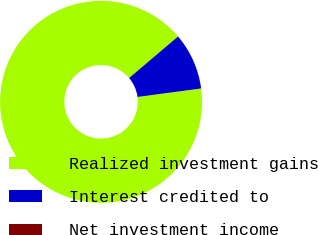Convert chart to OTSL. <chart><loc_0><loc_0><loc_500><loc_500><pie_chart><fcel>Realized investment gains<fcel>Interest credited to<fcel>Net investment income<nl><fcel>90.9%<fcel>9.09%<fcel>0.0%<nl></chart> 